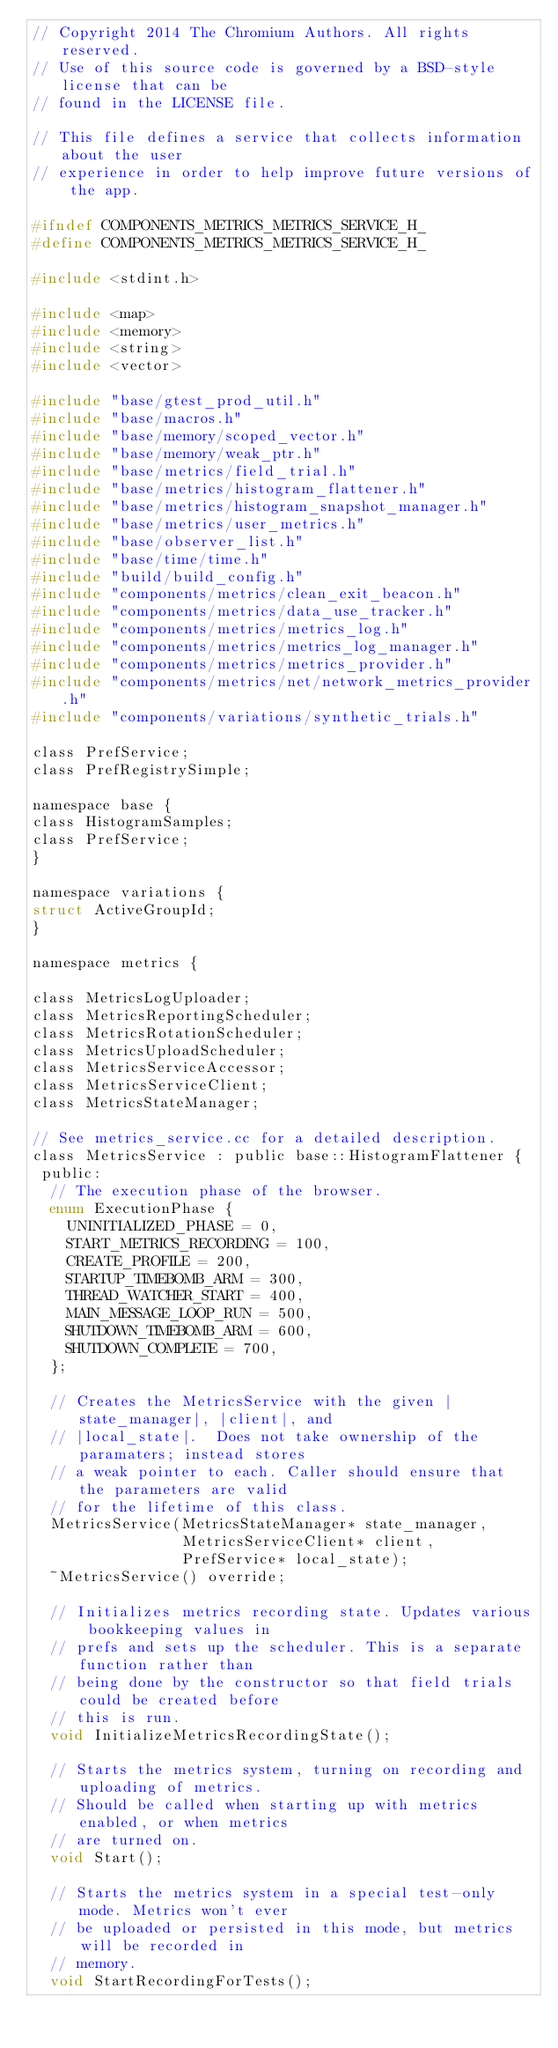Convert code to text. <code><loc_0><loc_0><loc_500><loc_500><_C_>// Copyright 2014 The Chromium Authors. All rights reserved.
// Use of this source code is governed by a BSD-style license that can be
// found in the LICENSE file.

// This file defines a service that collects information about the user
// experience in order to help improve future versions of the app.

#ifndef COMPONENTS_METRICS_METRICS_SERVICE_H_
#define COMPONENTS_METRICS_METRICS_SERVICE_H_

#include <stdint.h>

#include <map>
#include <memory>
#include <string>
#include <vector>

#include "base/gtest_prod_util.h"
#include "base/macros.h"
#include "base/memory/scoped_vector.h"
#include "base/memory/weak_ptr.h"
#include "base/metrics/field_trial.h"
#include "base/metrics/histogram_flattener.h"
#include "base/metrics/histogram_snapshot_manager.h"
#include "base/metrics/user_metrics.h"
#include "base/observer_list.h"
#include "base/time/time.h"
#include "build/build_config.h"
#include "components/metrics/clean_exit_beacon.h"
#include "components/metrics/data_use_tracker.h"
#include "components/metrics/metrics_log.h"
#include "components/metrics/metrics_log_manager.h"
#include "components/metrics/metrics_provider.h"
#include "components/metrics/net/network_metrics_provider.h"
#include "components/variations/synthetic_trials.h"

class PrefService;
class PrefRegistrySimple;

namespace base {
class HistogramSamples;
class PrefService;
}

namespace variations {
struct ActiveGroupId;
}

namespace metrics {

class MetricsLogUploader;
class MetricsReportingScheduler;
class MetricsRotationScheduler;
class MetricsUploadScheduler;
class MetricsServiceAccessor;
class MetricsServiceClient;
class MetricsStateManager;

// See metrics_service.cc for a detailed description.
class MetricsService : public base::HistogramFlattener {
 public:
  // The execution phase of the browser.
  enum ExecutionPhase {
    UNINITIALIZED_PHASE = 0,
    START_METRICS_RECORDING = 100,
    CREATE_PROFILE = 200,
    STARTUP_TIMEBOMB_ARM = 300,
    THREAD_WATCHER_START = 400,
    MAIN_MESSAGE_LOOP_RUN = 500,
    SHUTDOWN_TIMEBOMB_ARM = 600,
    SHUTDOWN_COMPLETE = 700,
  };

  // Creates the MetricsService with the given |state_manager|, |client|, and
  // |local_state|.  Does not take ownership of the paramaters; instead stores
  // a weak pointer to each. Caller should ensure that the parameters are valid
  // for the lifetime of this class.
  MetricsService(MetricsStateManager* state_manager,
                 MetricsServiceClient* client,
                 PrefService* local_state);
  ~MetricsService() override;

  // Initializes metrics recording state. Updates various bookkeeping values in
  // prefs and sets up the scheduler. This is a separate function rather than
  // being done by the constructor so that field trials could be created before
  // this is run.
  void InitializeMetricsRecordingState();

  // Starts the metrics system, turning on recording and uploading of metrics.
  // Should be called when starting up with metrics enabled, or when metrics
  // are turned on.
  void Start();

  // Starts the metrics system in a special test-only mode. Metrics won't ever
  // be uploaded or persisted in this mode, but metrics will be recorded in
  // memory.
  void StartRecordingForTests();
</code> 